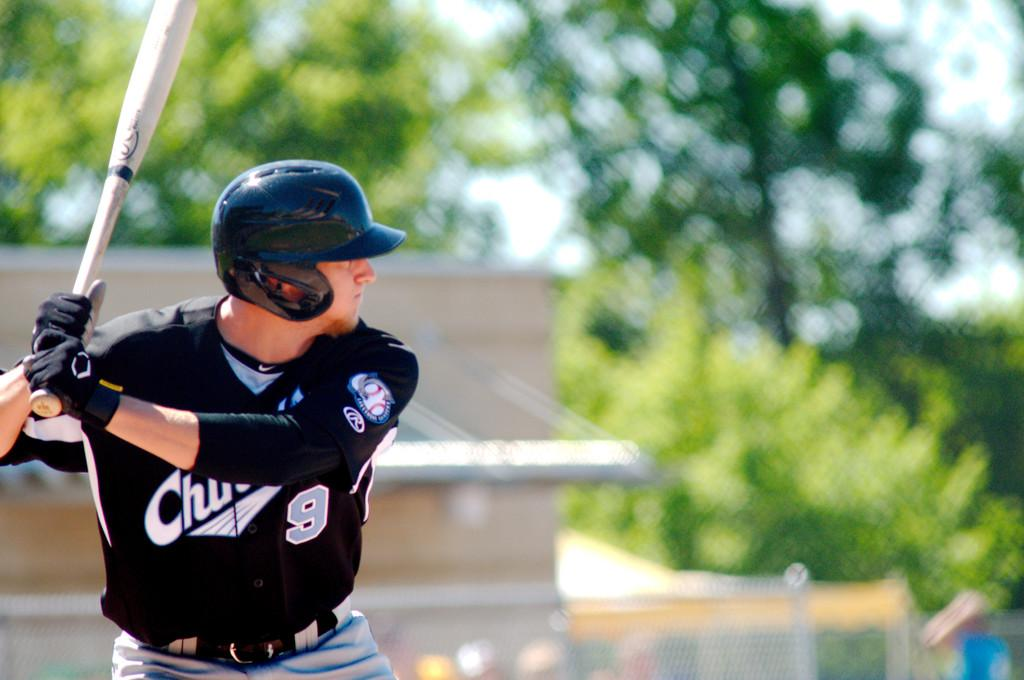Who is present in the image? There is a man in the image. What is the man holding in the image? The man is holding a baseball bat. What can be seen in the background of the image? There are trees and a house in the background of the image. What type of curtain is hanging in the background of the image? There is no curtain present in the background of the image. What is the man's afterthought while holding the baseball bat in the image? The image does not provide information about the man's thoughts or emotions, so we cannot determine his afterthought. 